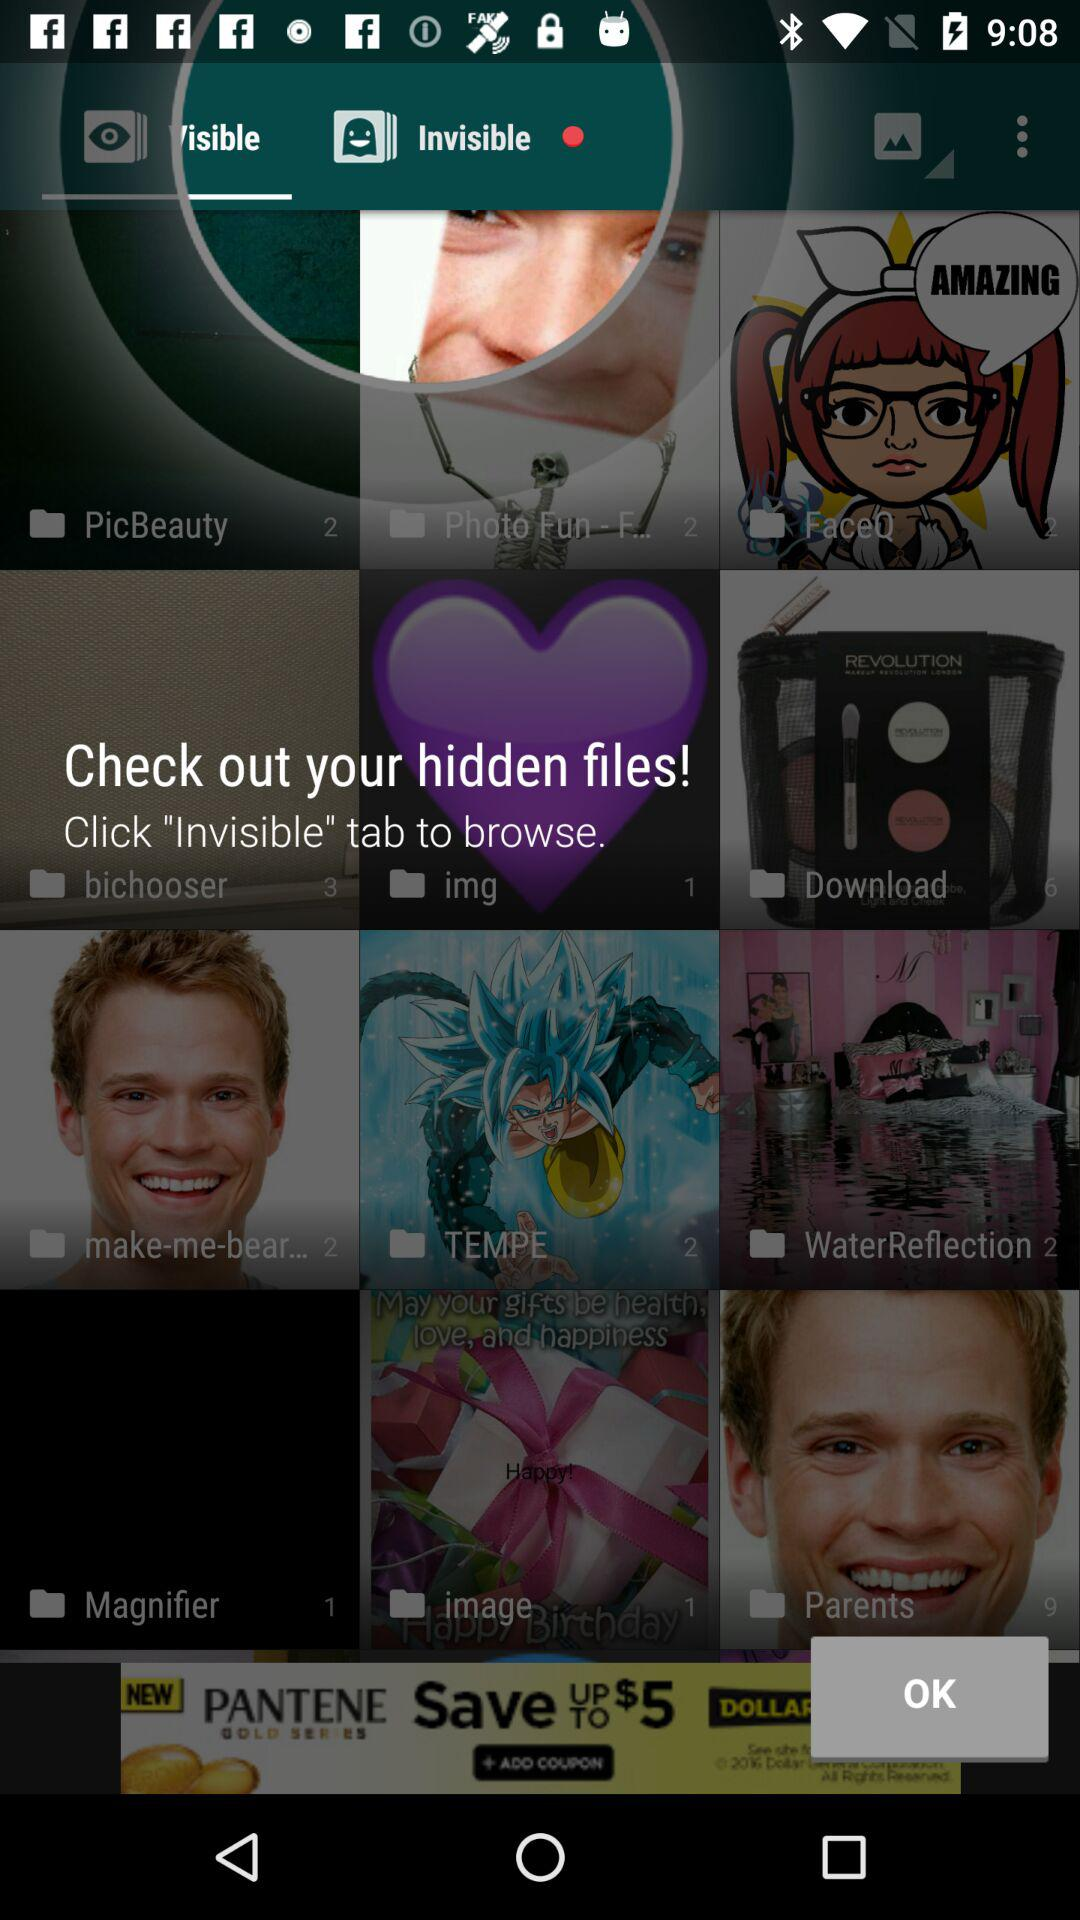Where can the hidden files be seen? The hidden files can be seen in the "Invisible" tab. 